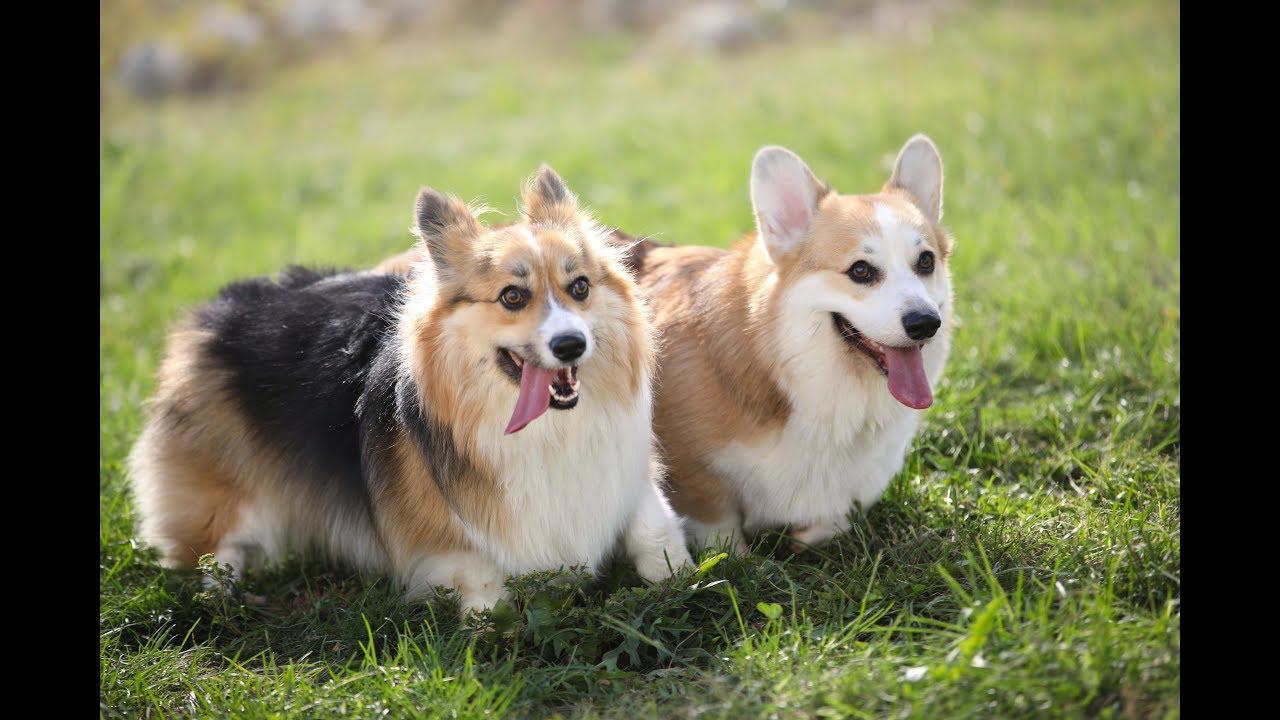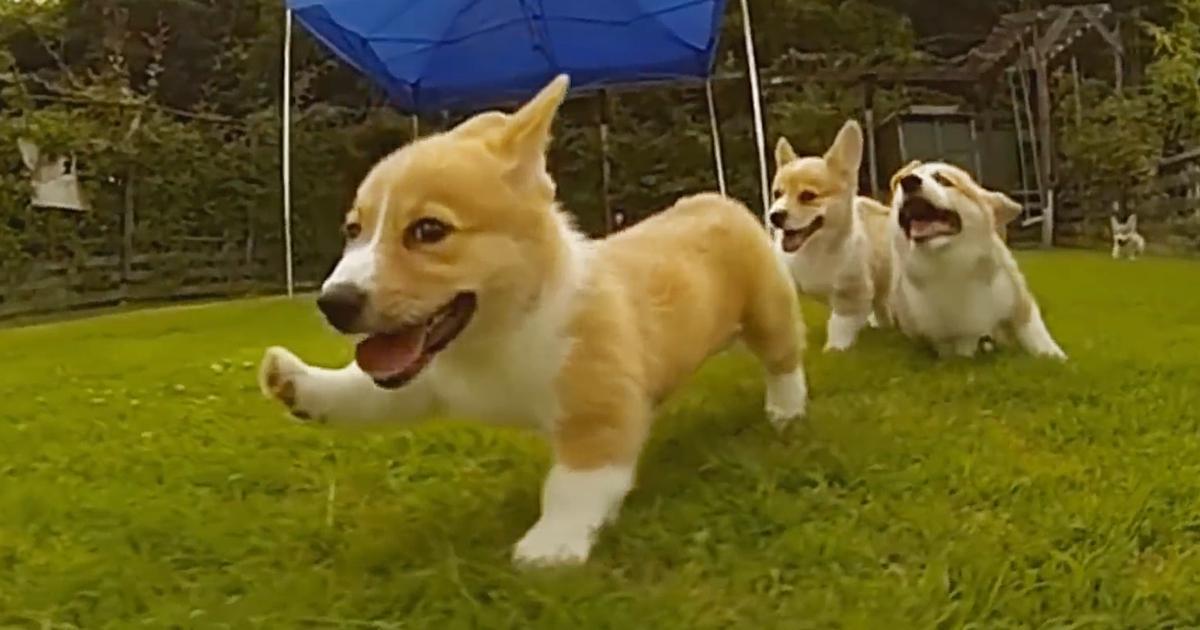The first image is the image on the left, the second image is the image on the right. Evaluate the accuracy of this statement regarding the images: "One image shows three corgi dogs running across the grass, with one dog in the lead, and a blue tent canopy behind them.". Is it true? Answer yes or no. Yes. The first image is the image on the left, the second image is the image on the right. Considering the images on both sides, is "At least one puppy has both front paws off the ground." valid? Answer yes or no. No. 